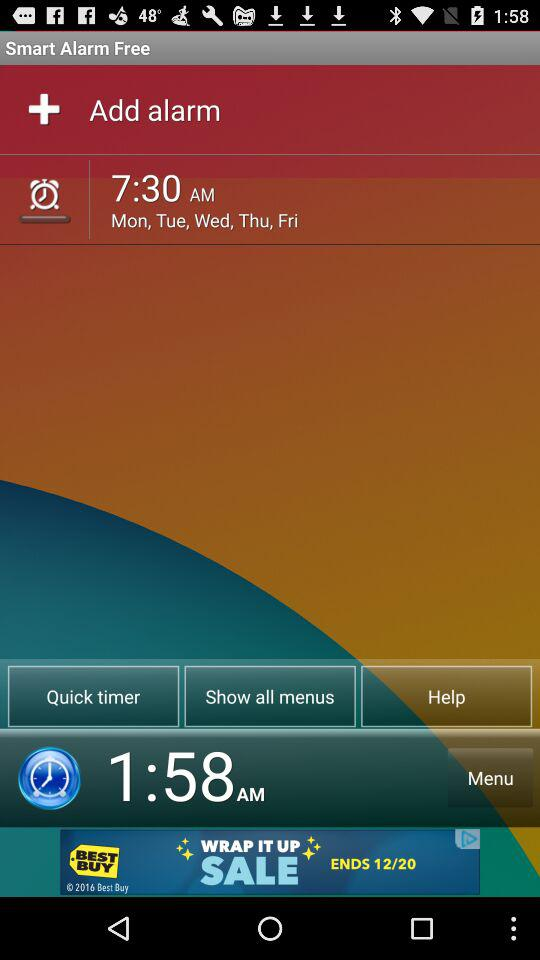What is the application name? The application name is "SMART ALARM". 